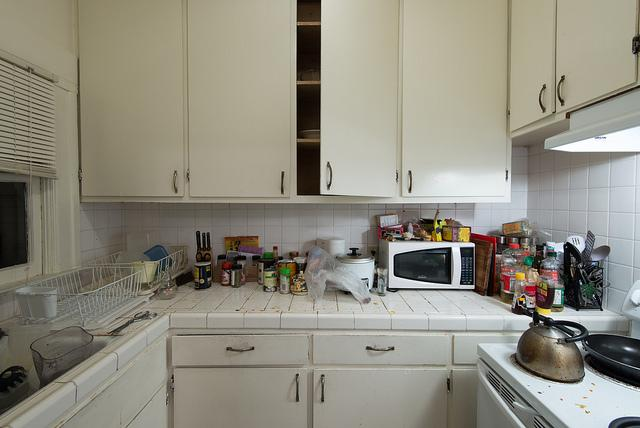Why is there a dish drainer on the counter?

Choices:
A) ambiance
B) cooking utensil
C) vegetable storage
D) no dishwasher no dishwasher 